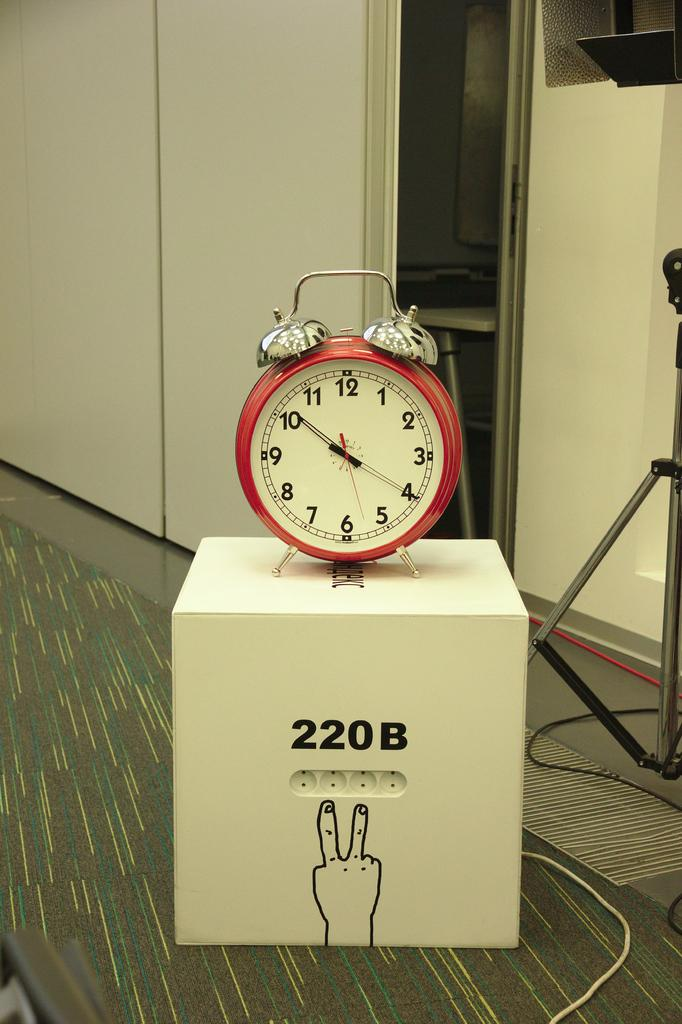<image>
Provide a brief description of the given image. a clock that says it is 10:20 on it 